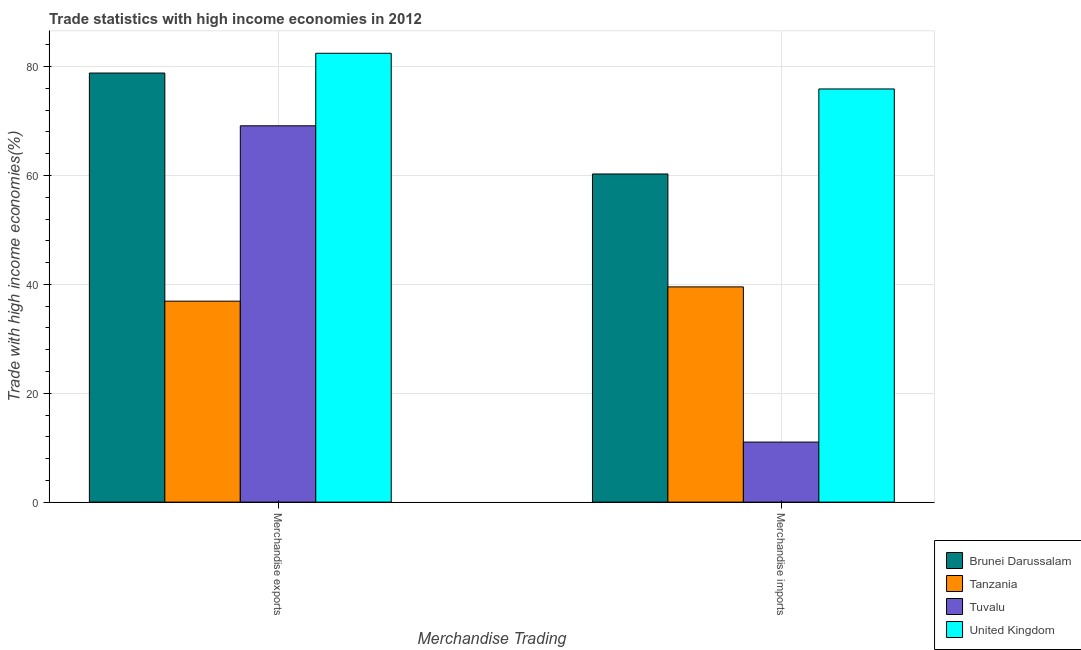How many different coloured bars are there?
Keep it short and to the point. 4. How many groups of bars are there?
Give a very brief answer. 2. What is the label of the 2nd group of bars from the left?
Provide a short and direct response. Merchandise imports. What is the merchandise imports in Brunei Darussalam?
Provide a succinct answer. 60.28. Across all countries, what is the maximum merchandise exports?
Your answer should be compact. 82.45. Across all countries, what is the minimum merchandise exports?
Keep it short and to the point. 36.92. In which country was the merchandise imports minimum?
Provide a short and direct response. Tuvalu. What is the total merchandise exports in the graph?
Provide a short and direct response. 267.32. What is the difference between the merchandise imports in Tanzania and that in United Kingdom?
Your answer should be very brief. -36.36. What is the difference between the merchandise exports in United Kingdom and the merchandise imports in Tuvalu?
Offer a terse response. 71.43. What is the average merchandise exports per country?
Ensure brevity in your answer.  66.83. What is the difference between the merchandise exports and merchandise imports in Brunei Darussalam?
Offer a very short reply. 18.54. In how many countries, is the merchandise imports greater than 64 %?
Your answer should be compact. 1. What is the ratio of the merchandise imports in Tuvalu to that in Tanzania?
Make the answer very short. 0.28. In how many countries, is the merchandise imports greater than the average merchandise imports taken over all countries?
Keep it short and to the point. 2. What does the 1st bar from the left in Merchandise exports represents?
Provide a succinct answer. Brunei Darussalam. What does the 2nd bar from the right in Merchandise imports represents?
Provide a succinct answer. Tuvalu. What is the difference between two consecutive major ticks on the Y-axis?
Offer a terse response. 20. Does the graph contain any zero values?
Your answer should be compact. No. How many legend labels are there?
Your answer should be very brief. 4. How are the legend labels stacked?
Your answer should be very brief. Vertical. What is the title of the graph?
Offer a very short reply. Trade statistics with high income economies in 2012. What is the label or title of the X-axis?
Provide a short and direct response. Merchandise Trading. What is the label or title of the Y-axis?
Offer a very short reply. Trade with high income economies(%). What is the Trade with high income economies(%) of Brunei Darussalam in Merchandise exports?
Your response must be concise. 78.82. What is the Trade with high income economies(%) in Tanzania in Merchandise exports?
Your response must be concise. 36.92. What is the Trade with high income economies(%) of Tuvalu in Merchandise exports?
Give a very brief answer. 69.13. What is the Trade with high income economies(%) of United Kingdom in Merchandise exports?
Offer a very short reply. 82.45. What is the Trade with high income economies(%) in Brunei Darussalam in Merchandise imports?
Provide a succinct answer. 60.28. What is the Trade with high income economies(%) in Tanzania in Merchandise imports?
Provide a succinct answer. 39.54. What is the Trade with high income economies(%) in Tuvalu in Merchandise imports?
Your answer should be very brief. 11.03. What is the Trade with high income economies(%) in United Kingdom in Merchandise imports?
Your response must be concise. 75.9. Across all Merchandise Trading, what is the maximum Trade with high income economies(%) of Brunei Darussalam?
Make the answer very short. 78.82. Across all Merchandise Trading, what is the maximum Trade with high income economies(%) of Tanzania?
Ensure brevity in your answer.  39.54. Across all Merchandise Trading, what is the maximum Trade with high income economies(%) in Tuvalu?
Keep it short and to the point. 69.13. Across all Merchandise Trading, what is the maximum Trade with high income economies(%) in United Kingdom?
Offer a terse response. 82.45. Across all Merchandise Trading, what is the minimum Trade with high income economies(%) of Brunei Darussalam?
Your answer should be very brief. 60.28. Across all Merchandise Trading, what is the minimum Trade with high income economies(%) of Tanzania?
Your answer should be very brief. 36.92. Across all Merchandise Trading, what is the minimum Trade with high income economies(%) of Tuvalu?
Give a very brief answer. 11.03. Across all Merchandise Trading, what is the minimum Trade with high income economies(%) of United Kingdom?
Give a very brief answer. 75.9. What is the total Trade with high income economies(%) of Brunei Darussalam in the graph?
Your answer should be compact. 139.1. What is the total Trade with high income economies(%) of Tanzania in the graph?
Give a very brief answer. 76.46. What is the total Trade with high income economies(%) in Tuvalu in the graph?
Provide a succinct answer. 80.16. What is the total Trade with high income economies(%) of United Kingdom in the graph?
Offer a very short reply. 158.35. What is the difference between the Trade with high income economies(%) of Brunei Darussalam in Merchandise exports and that in Merchandise imports?
Make the answer very short. 18.54. What is the difference between the Trade with high income economies(%) in Tanzania in Merchandise exports and that in Merchandise imports?
Your answer should be compact. -2.62. What is the difference between the Trade with high income economies(%) of Tuvalu in Merchandise exports and that in Merchandise imports?
Your response must be concise. 58.1. What is the difference between the Trade with high income economies(%) in United Kingdom in Merchandise exports and that in Merchandise imports?
Your response must be concise. 6.56. What is the difference between the Trade with high income economies(%) in Brunei Darussalam in Merchandise exports and the Trade with high income economies(%) in Tanzania in Merchandise imports?
Your response must be concise. 39.28. What is the difference between the Trade with high income economies(%) in Brunei Darussalam in Merchandise exports and the Trade with high income economies(%) in Tuvalu in Merchandise imports?
Provide a succinct answer. 67.79. What is the difference between the Trade with high income economies(%) in Brunei Darussalam in Merchandise exports and the Trade with high income economies(%) in United Kingdom in Merchandise imports?
Keep it short and to the point. 2.93. What is the difference between the Trade with high income economies(%) in Tanzania in Merchandise exports and the Trade with high income economies(%) in Tuvalu in Merchandise imports?
Provide a short and direct response. 25.89. What is the difference between the Trade with high income economies(%) in Tanzania in Merchandise exports and the Trade with high income economies(%) in United Kingdom in Merchandise imports?
Provide a short and direct response. -38.98. What is the difference between the Trade with high income economies(%) in Tuvalu in Merchandise exports and the Trade with high income economies(%) in United Kingdom in Merchandise imports?
Provide a succinct answer. -6.77. What is the average Trade with high income economies(%) of Brunei Darussalam per Merchandise Trading?
Provide a short and direct response. 69.55. What is the average Trade with high income economies(%) of Tanzania per Merchandise Trading?
Give a very brief answer. 38.23. What is the average Trade with high income economies(%) in Tuvalu per Merchandise Trading?
Offer a very short reply. 40.08. What is the average Trade with high income economies(%) of United Kingdom per Merchandise Trading?
Provide a succinct answer. 79.18. What is the difference between the Trade with high income economies(%) of Brunei Darussalam and Trade with high income economies(%) of Tanzania in Merchandise exports?
Provide a succinct answer. 41.91. What is the difference between the Trade with high income economies(%) of Brunei Darussalam and Trade with high income economies(%) of Tuvalu in Merchandise exports?
Make the answer very short. 9.69. What is the difference between the Trade with high income economies(%) in Brunei Darussalam and Trade with high income economies(%) in United Kingdom in Merchandise exports?
Provide a succinct answer. -3.63. What is the difference between the Trade with high income economies(%) in Tanzania and Trade with high income economies(%) in Tuvalu in Merchandise exports?
Your answer should be very brief. -32.21. What is the difference between the Trade with high income economies(%) of Tanzania and Trade with high income economies(%) of United Kingdom in Merchandise exports?
Ensure brevity in your answer.  -45.54. What is the difference between the Trade with high income economies(%) in Tuvalu and Trade with high income economies(%) in United Kingdom in Merchandise exports?
Your answer should be very brief. -13.32. What is the difference between the Trade with high income economies(%) of Brunei Darussalam and Trade with high income economies(%) of Tanzania in Merchandise imports?
Offer a terse response. 20.74. What is the difference between the Trade with high income economies(%) of Brunei Darussalam and Trade with high income economies(%) of Tuvalu in Merchandise imports?
Your answer should be very brief. 49.25. What is the difference between the Trade with high income economies(%) of Brunei Darussalam and Trade with high income economies(%) of United Kingdom in Merchandise imports?
Keep it short and to the point. -15.62. What is the difference between the Trade with high income economies(%) of Tanzania and Trade with high income economies(%) of Tuvalu in Merchandise imports?
Offer a very short reply. 28.51. What is the difference between the Trade with high income economies(%) of Tanzania and Trade with high income economies(%) of United Kingdom in Merchandise imports?
Make the answer very short. -36.36. What is the difference between the Trade with high income economies(%) in Tuvalu and Trade with high income economies(%) in United Kingdom in Merchandise imports?
Give a very brief answer. -64.87. What is the ratio of the Trade with high income economies(%) of Brunei Darussalam in Merchandise exports to that in Merchandise imports?
Your answer should be very brief. 1.31. What is the ratio of the Trade with high income economies(%) in Tanzania in Merchandise exports to that in Merchandise imports?
Your answer should be very brief. 0.93. What is the ratio of the Trade with high income economies(%) in Tuvalu in Merchandise exports to that in Merchandise imports?
Your answer should be very brief. 6.27. What is the ratio of the Trade with high income economies(%) in United Kingdom in Merchandise exports to that in Merchandise imports?
Provide a succinct answer. 1.09. What is the difference between the highest and the second highest Trade with high income economies(%) of Brunei Darussalam?
Give a very brief answer. 18.54. What is the difference between the highest and the second highest Trade with high income economies(%) in Tanzania?
Your answer should be compact. 2.62. What is the difference between the highest and the second highest Trade with high income economies(%) in Tuvalu?
Give a very brief answer. 58.1. What is the difference between the highest and the second highest Trade with high income economies(%) of United Kingdom?
Provide a short and direct response. 6.56. What is the difference between the highest and the lowest Trade with high income economies(%) of Brunei Darussalam?
Keep it short and to the point. 18.54. What is the difference between the highest and the lowest Trade with high income economies(%) of Tanzania?
Give a very brief answer. 2.62. What is the difference between the highest and the lowest Trade with high income economies(%) in Tuvalu?
Provide a succinct answer. 58.1. What is the difference between the highest and the lowest Trade with high income economies(%) in United Kingdom?
Your answer should be compact. 6.56. 